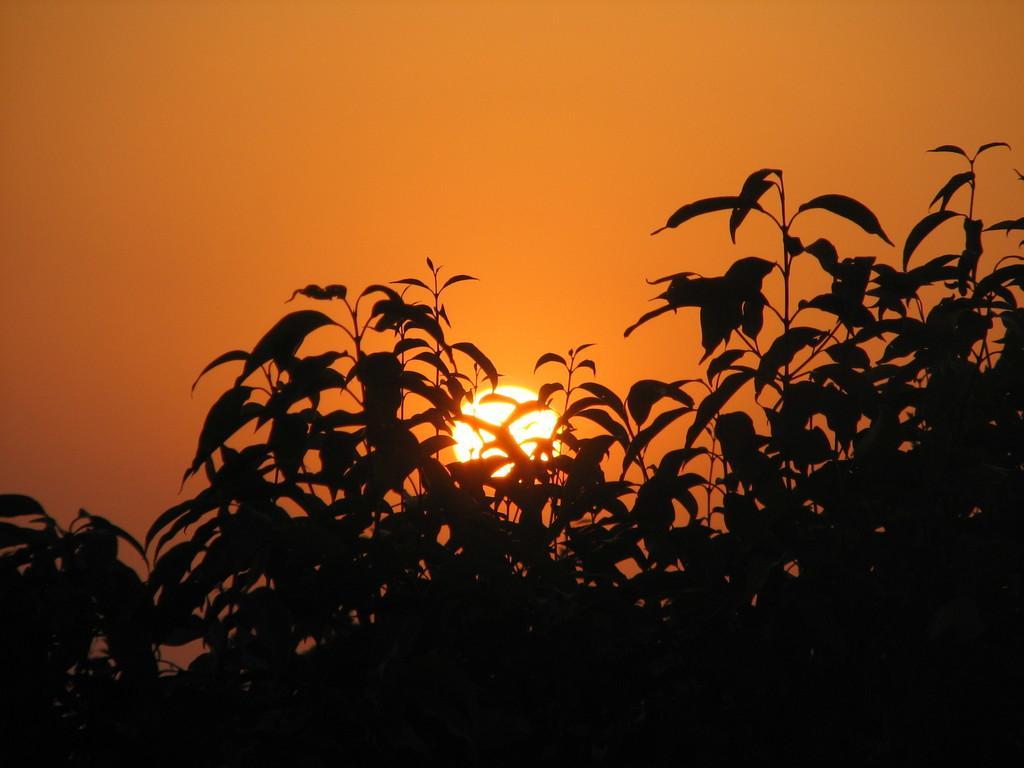Could you give a brief overview of what you see in this image? In this image there is a sun, trees and the sky. 